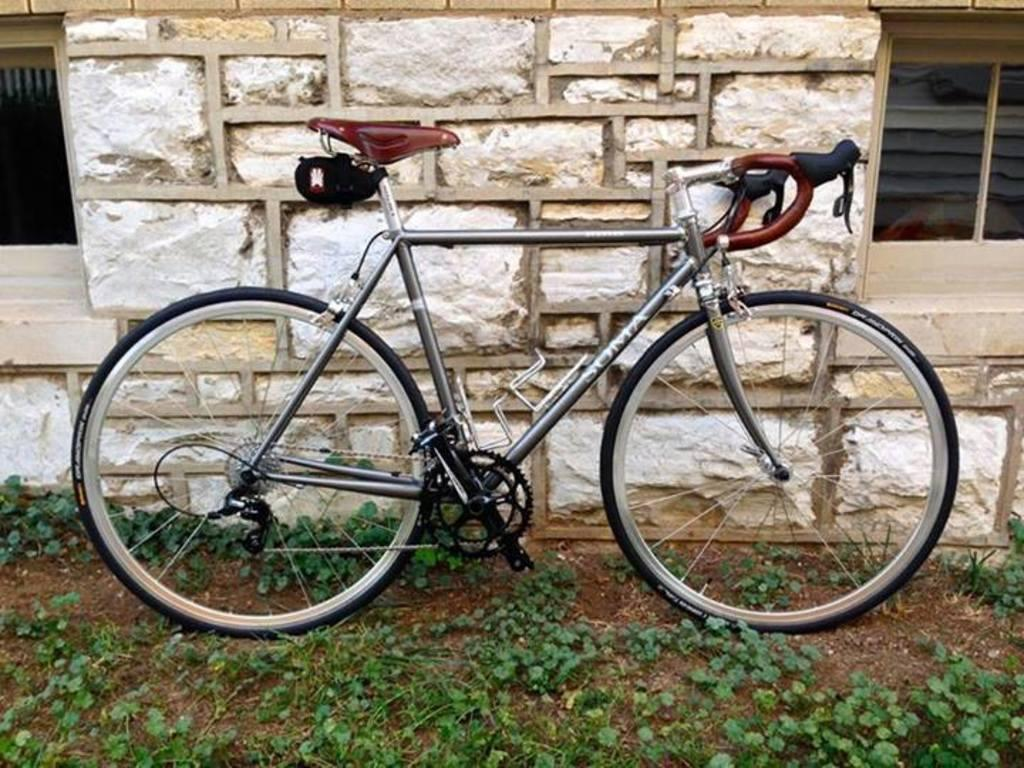What type of surface is on the ground in the image? There is grass on the ground in the image. What is the main object in the center of the image? There is a bicycle in the center of the image. What can be seen in the background of the image? There is a wall and windows visible in the background. What type of fruit can be seen hanging from the bicycle in the image? There is no fruit hanging from the bicycle in the image. What type of honey is being used to decorate the wall in the image? There is no honey present in the image; it features a wall with windows. 